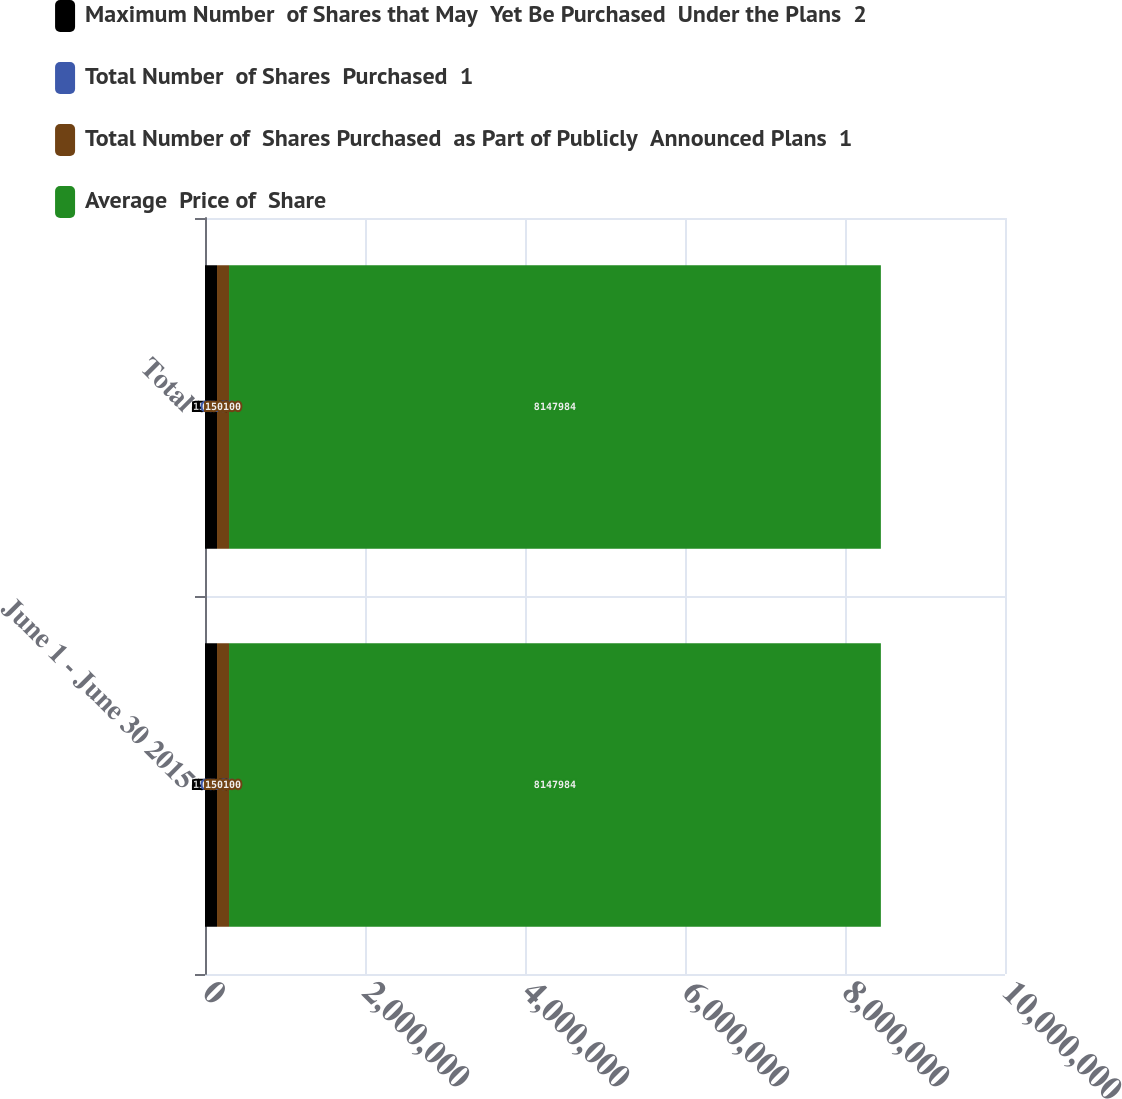<chart> <loc_0><loc_0><loc_500><loc_500><stacked_bar_chart><ecel><fcel>June 1 - June 30 2015<fcel>Total<nl><fcel>Maximum Number  of Shares that May  Yet Be Purchased  Under the Plans  2<fcel>150146<fcel>150146<nl><fcel>Total Number  of Shares  Purchased  1<fcel>65.87<fcel>65.87<nl><fcel>Total Number of  Shares Purchased  as Part of Publicly  Announced Plans  1<fcel>150100<fcel>150100<nl><fcel>Average  Price of  Share<fcel>8.14798e+06<fcel>8.14798e+06<nl></chart> 